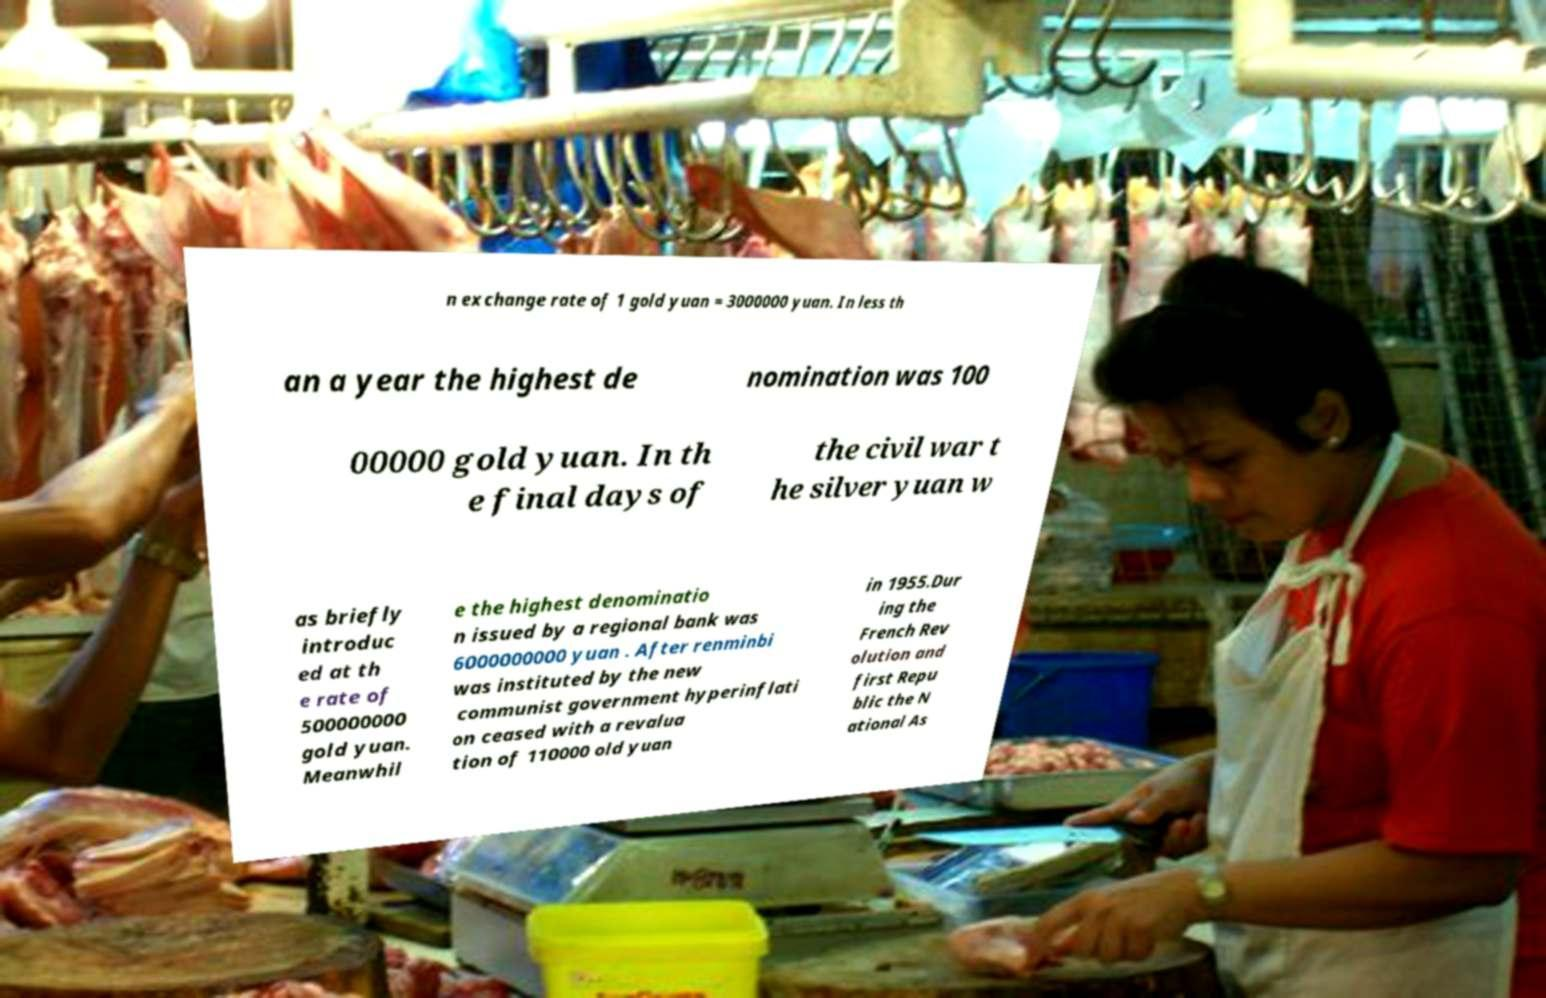I need the written content from this picture converted into text. Can you do that? n exchange rate of 1 gold yuan = 3000000 yuan. In less th an a year the highest de nomination was 100 00000 gold yuan. In th e final days of the civil war t he silver yuan w as briefly introduc ed at th e rate of 500000000 gold yuan. Meanwhil e the highest denominatio n issued by a regional bank was 6000000000 yuan . After renminbi was instituted by the new communist government hyperinflati on ceased with a revalua tion of 110000 old yuan in 1955.Dur ing the French Rev olution and first Repu blic the N ational As 